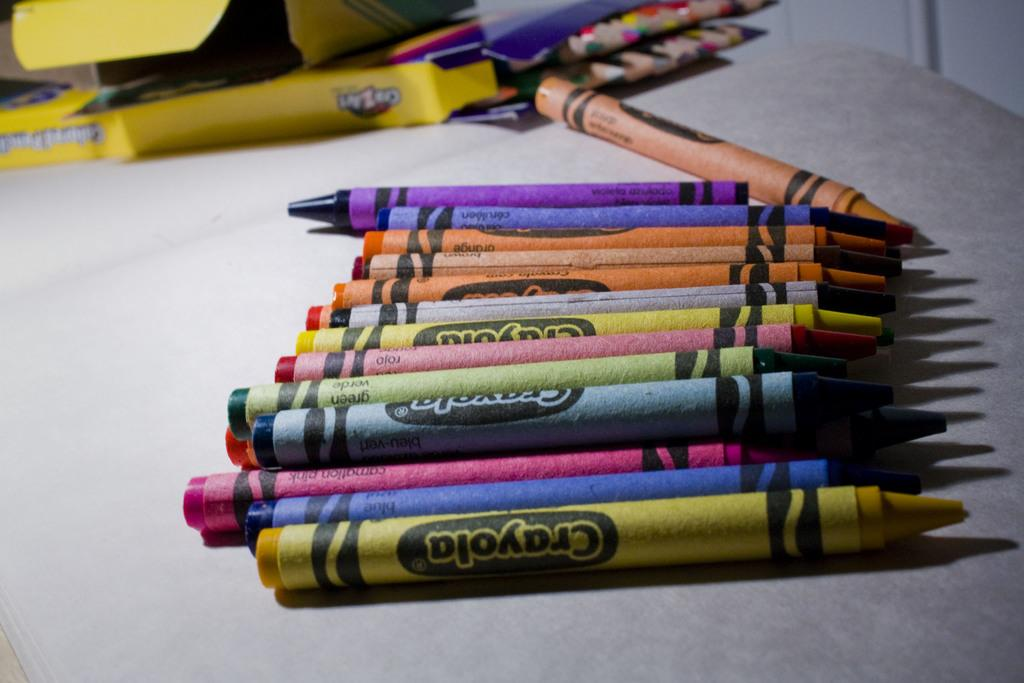<image>
Provide a brief description of the given image. Many different color crayola crayons are laid out together. 